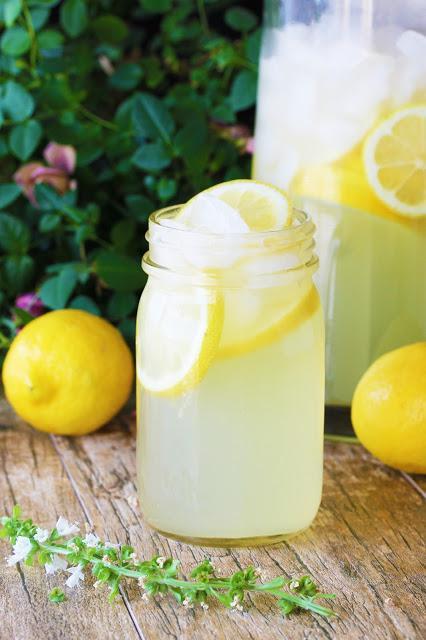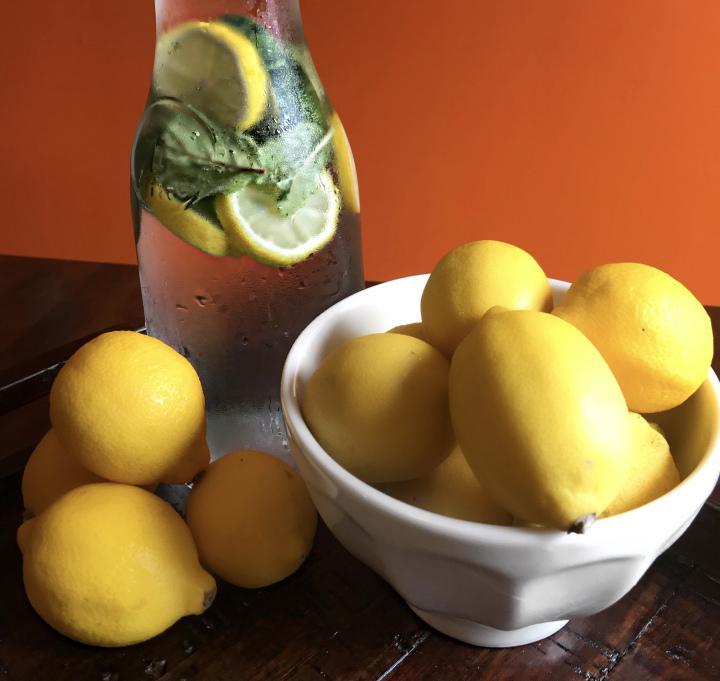The first image is the image on the left, the second image is the image on the right. Evaluate the accuracy of this statement regarding the images: "In at least one image there is a lemon in front of a rounded lemonade pitcher.". Is it true? Answer yes or no. No. 